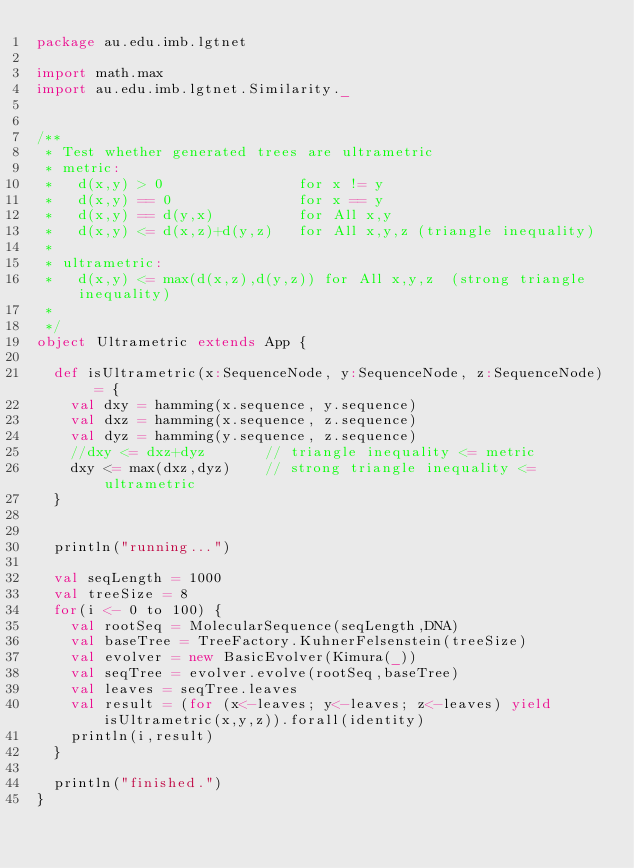Convert code to text. <code><loc_0><loc_0><loc_500><loc_500><_Scala_>package au.edu.imb.lgtnet

import math.max
import au.edu.imb.lgtnet.Similarity._


/**
 * Test whether generated trees are ultrametric
 * metric:
 *   d(x,y) > 0                for x != y
 *   d(x,y) == 0               for x == y
 *   d(x,y) == d(y,x)          for All x,y
 *   d(x,y) <= d(x,z)+d(y,z)   for All x,y,z (triangle inequality)
 *
 * ultrametric:
 *   d(x,y) <= max(d(x,z),d(y,z)) for All x,y,z  (strong triangle inequality)
 *
 */
object Ultrametric extends App {

  def isUltrametric(x:SequenceNode, y:SequenceNode, z:SequenceNode) = {
    val dxy = hamming(x.sequence, y.sequence)
    val dxz = hamming(x.sequence, z.sequence)
    val dyz = hamming(y.sequence, z.sequence)
    //dxy <= dxz+dyz       // triangle inequality <= metric
    dxy <= max(dxz,dyz)    // strong triangle inequality <= ultrametric
  }


  println("running...")

  val seqLength = 1000
  val treeSize = 8
  for(i <- 0 to 100) {
    val rootSeq = MolecularSequence(seqLength,DNA)
    val baseTree = TreeFactory.KuhnerFelsenstein(treeSize)
    val evolver = new BasicEvolver(Kimura(_))
    val seqTree = evolver.evolve(rootSeq,baseTree)
    val leaves = seqTree.leaves
    val result = (for (x<-leaves; y<-leaves; z<-leaves) yield isUltrametric(x,y,z)).forall(identity)
    println(i,result)
  }

  println("finished.")
}
</code> 